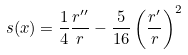Convert formula to latex. <formula><loc_0><loc_0><loc_500><loc_500>s ( x ) = \frac { 1 } { 4 } \frac { r ^ { \prime \prime } } { r } - \frac { 5 } { 1 6 } \left ( \frac { r ^ { \prime } } { r } \right ) ^ { 2 }</formula> 